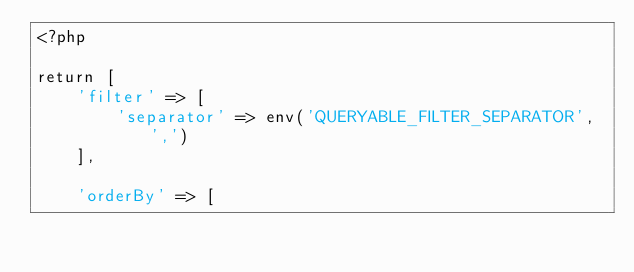Convert code to text. <code><loc_0><loc_0><loc_500><loc_500><_PHP_><?php

return [
    'filter' => [
        'separator' => env('QUERYABLE_FILTER_SEPARATOR', ',')
    ],

    'orderBy' => [</code> 